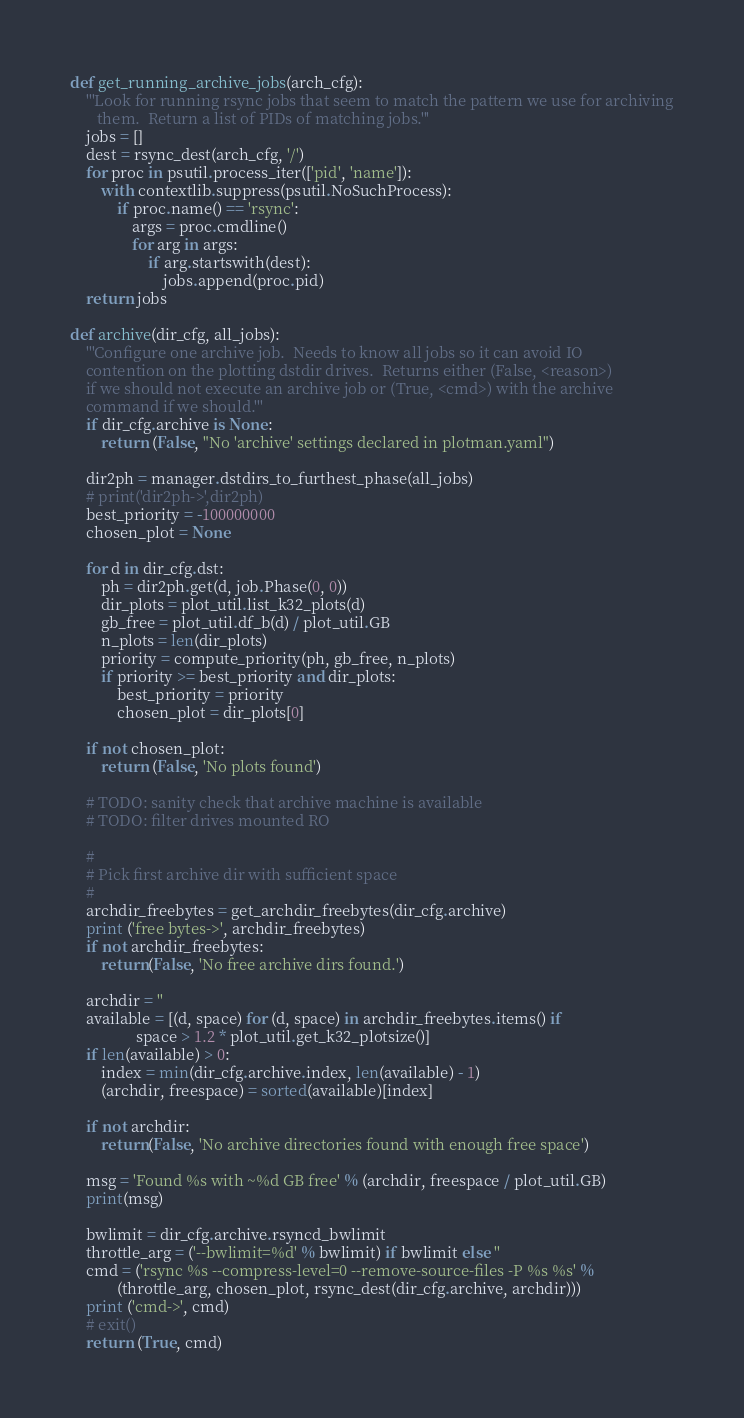<code> <loc_0><loc_0><loc_500><loc_500><_Python_>def get_running_archive_jobs(arch_cfg):
    '''Look for running rsync jobs that seem to match the pattern we use for archiving
       them.  Return a list of PIDs of matching jobs.'''
    jobs = []
    dest = rsync_dest(arch_cfg, '/')
    for proc in psutil.process_iter(['pid', 'name']):
        with contextlib.suppress(psutil.NoSuchProcess):
            if proc.name() == 'rsync':
                args = proc.cmdline()
                for arg in args:
                    if arg.startswith(dest):
                        jobs.append(proc.pid)
    return jobs

def archive(dir_cfg, all_jobs):
    '''Configure one archive job.  Needs to know all jobs so it can avoid IO
    contention on the plotting dstdir drives.  Returns either (False, <reason>)
    if we should not execute an archive job or (True, <cmd>) with the archive
    command if we should.'''
    if dir_cfg.archive is None:
        return (False, "No 'archive' settings declared in plotman.yaml")

    dir2ph = manager.dstdirs_to_furthest_phase(all_jobs)
    # print('dir2ph->',dir2ph)
    best_priority = -100000000
    chosen_plot = None

    for d in dir_cfg.dst:
        ph = dir2ph.get(d, job.Phase(0, 0))
        dir_plots = plot_util.list_k32_plots(d)
        gb_free = plot_util.df_b(d) / plot_util.GB
        n_plots = len(dir_plots)
        priority = compute_priority(ph, gb_free, n_plots)
        if priority >= best_priority and dir_plots:
            best_priority = priority
            chosen_plot = dir_plots[0]

    if not chosen_plot:
        return (False, 'No plots found')

    # TODO: sanity check that archive machine is available
    # TODO: filter drives mounted RO

    #
    # Pick first archive dir with sufficient space
    #
    archdir_freebytes = get_archdir_freebytes(dir_cfg.archive)
    print ('free bytes->', archdir_freebytes)
    if not archdir_freebytes:
        return(False, 'No free archive dirs found.')

    archdir = ''
    available = [(d, space) for (d, space) in archdir_freebytes.items() if
                 space > 1.2 * plot_util.get_k32_plotsize()]
    if len(available) > 0:
        index = min(dir_cfg.archive.index, len(available) - 1)
        (archdir, freespace) = sorted(available)[index]

    if not archdir:
        return(False, 'No archive directories found with enough free space')

    msg = 'Found %s with ~%d GB free' % (archdir, freespace / plot_util.GB)
    print(msg)

    bwlimit = dir_cfg.archive.rsyncd_bwlimit
    throttle_arg = ('--bwlimit=%d' % bwlimit) if bwlimit else ''
    cmd = ('rsync %s --compress-level=0 --remove-source-files -P %s %s' %
            (throttle_arg, chosen_plot, rsync_dest(dir_cfg.archive, archdir)))
    print ('cmd->', cmd)
    # exit()
    return (True, cmd)
</code> 